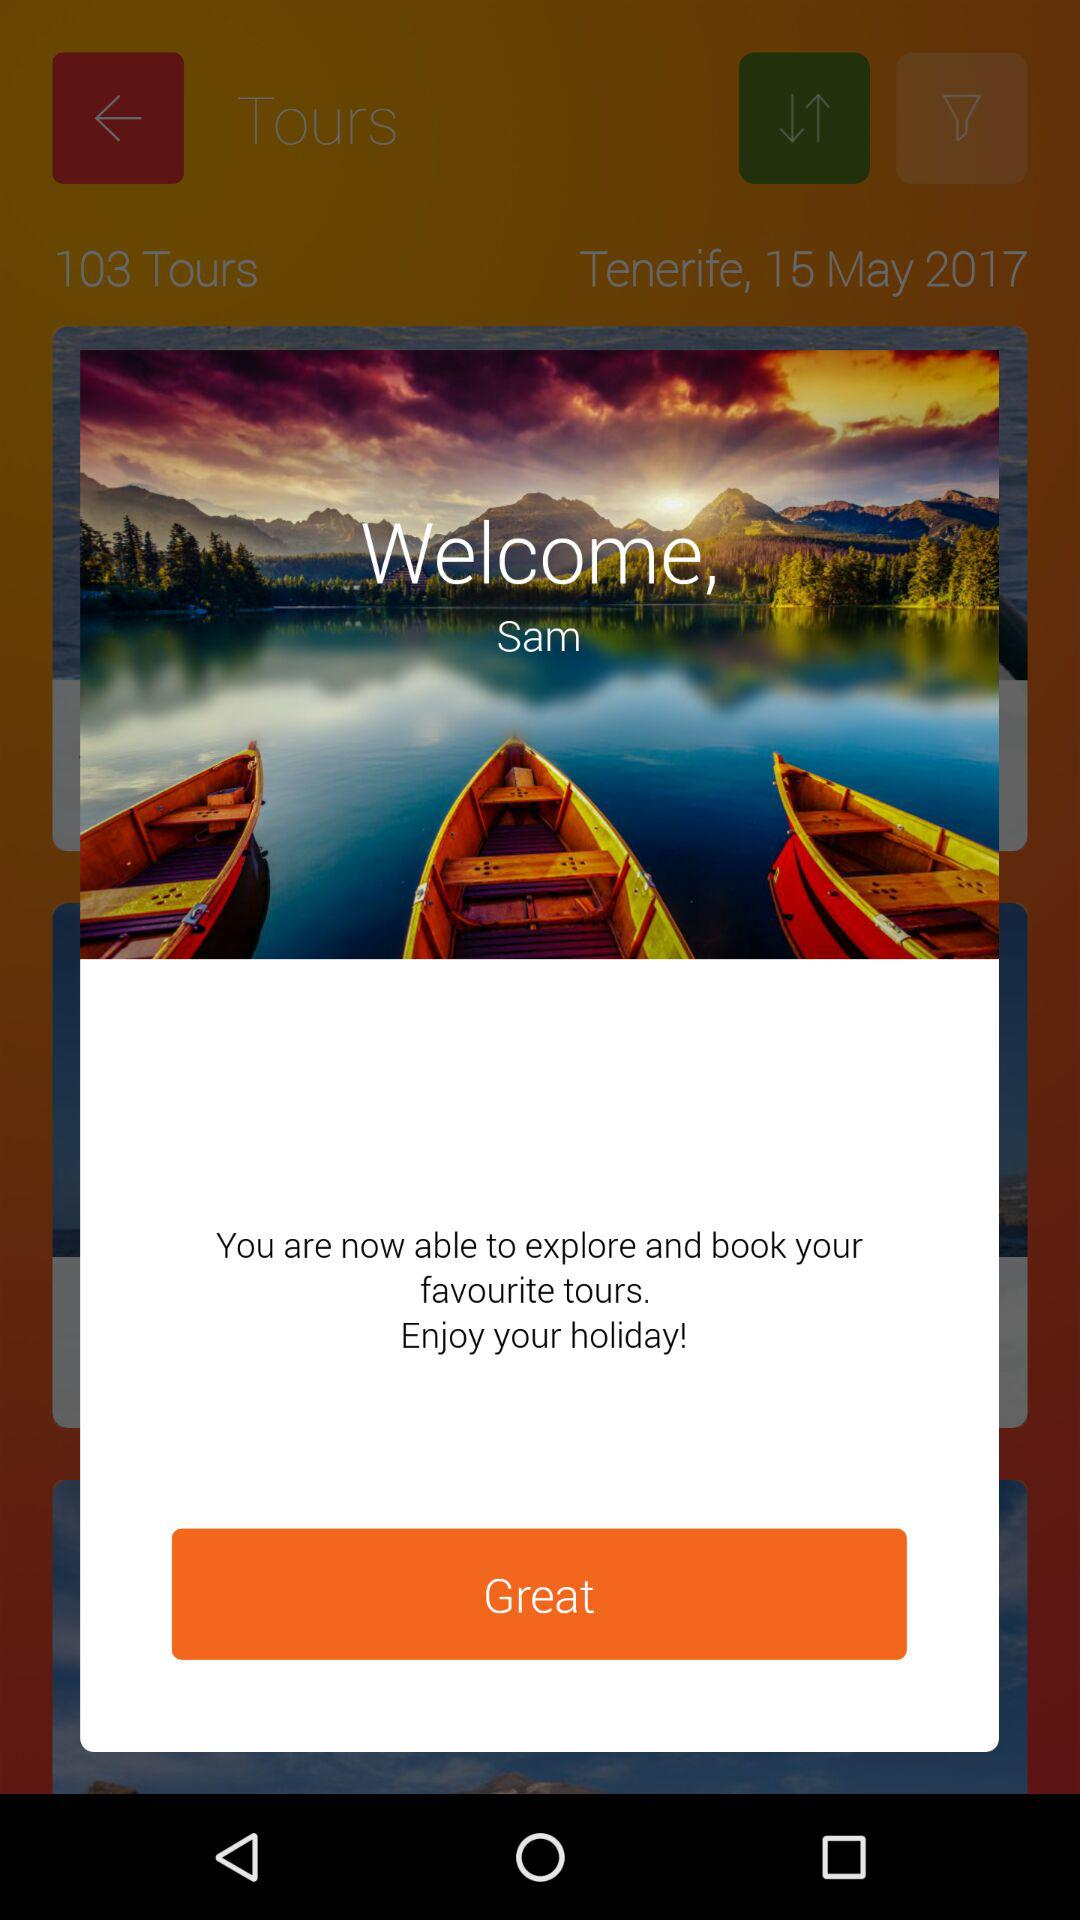How many tours in total have been shown? There are 103 tours in total. 